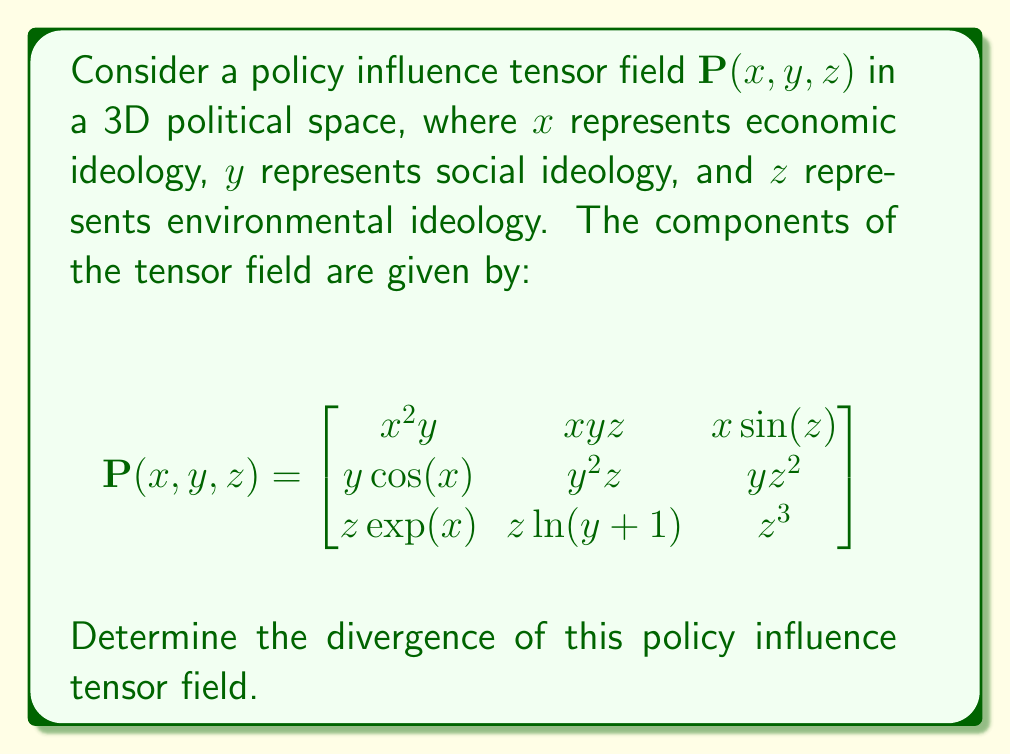Teach me how to tackle this problem. To find the divergence of the tensor field, we need to follow these steps:

1) The divergence of a tensor field in 3D is given by:

   $$\nabla \cdot \mathbf{P} = \frac{\partial P_{xx}}{\partial x} + \frac{\partial P_{yy}}{\partial y} + \frac{\partial P_{zz}}{\partial z}$$

   where $P_{xx}$, $P_{yy}$, and $P_{zz}$ are the diagonal elements of the tensor.

2) From the given tensor field:
   $P_{xx} = x^2y$
   $P_{yy} = y^2z$
   $P_{zz} = z^3$

3) Now, let's calculate each partial derivative:

   $\frac{\partial P_{xx}}{\partial x} = \frac{\partial (x^2y)}{\partial x} = 2xy$

   $\frac{\partial P_{yy}}{\partial y} = \frac{\partial (y^2z)}{\partial y} = 2yz$

   $\frac{\partial P_{zz}}{\partial z} = \frac{\partial (z^3)}{\partial z} = 3z^2$

4) Sum these partial derivatives:

   $$\nabla \cdot \mathbf{P} = 2xy + 2yz + 3z^2$$

This expression represents the divergence of the policy influence tensor field.
Answer: $2xy + 2yz + 3z^2$ 